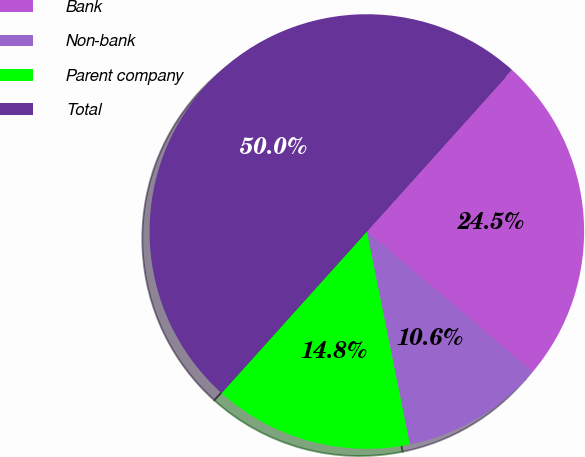Convert chart. <chart><loc_0><loc_0><loc_500><loc_500><pie_chart><fcel>Bank<fcel>Non-bank<fcel>Parent company<fcel>Total<nl><fcel>24.53%<fcel>10.64%<fcel>14.83%<fcel>50.0%<nl></chart> 